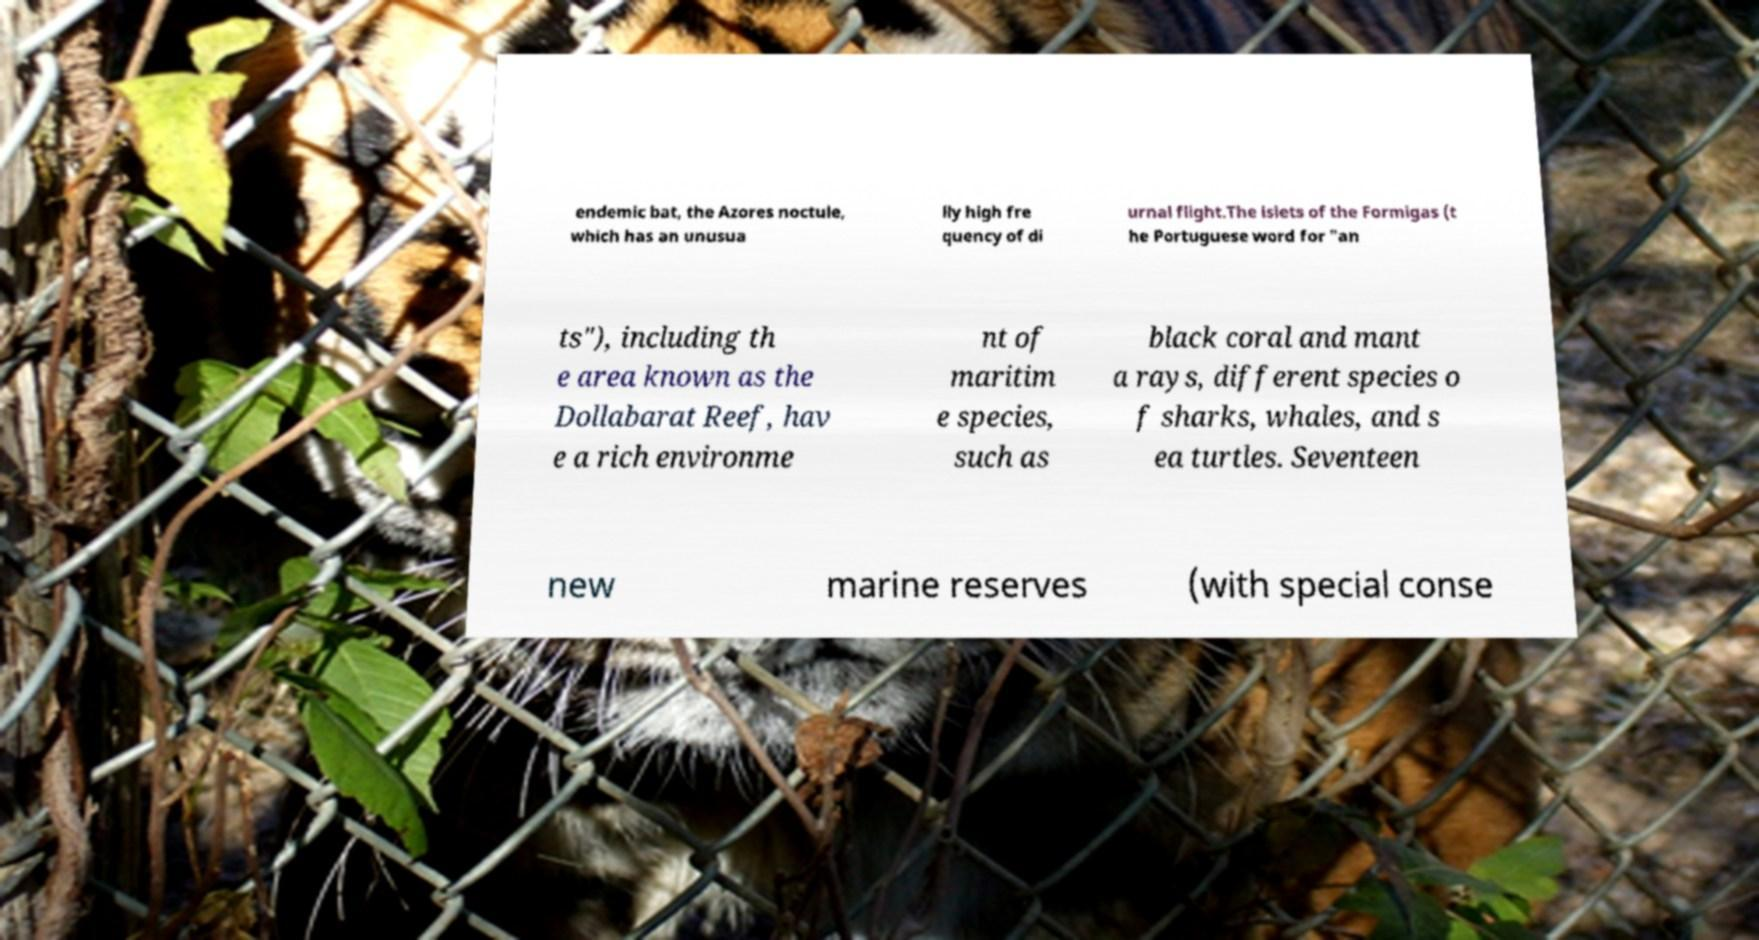Can you read and provide the text displayed in the image?This photo seems to have some interesting text. Can you extract and type it out for me? endemic bat, the Azores noctule, which has an unusua lly high fre quency of di urnal flight.The islets of the Formigas (t he Portuguese word for "an ts"), including th e area known as the Dollabarat Reef, hav e a rich environme nt of maritim e species, such as black coral and mant a rays, different species o f sharks, whales, and s ea turtles. Seventeen new marine reserves (with special conse 